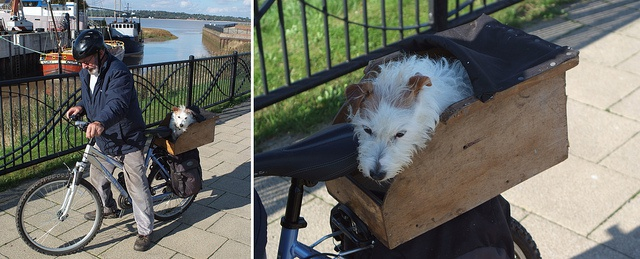Describe the objects in this image and their specific colors. I can see bicycle in gray, black, lightgray, and navy tones, bicycle in gray, darkgray, and black tones, dog in gray and darkgray tones, people in gray, black, and darkgray tones, and backpack in gray and black tones in this image. 